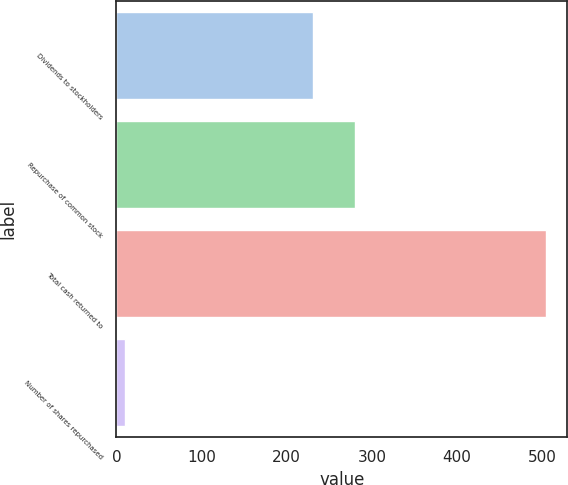<chart> <loc_0><loc_0><loc_500><loc_500><bar_chart><fcel>Dividends to stockholders<fcel>Repurchase of common stock<fcel>Total cash returned to<fcel>Number of shares repurchased<nl><fcel>231.3<fcel>280.65<fcel>504<fcel>10.5<nl></chart> 